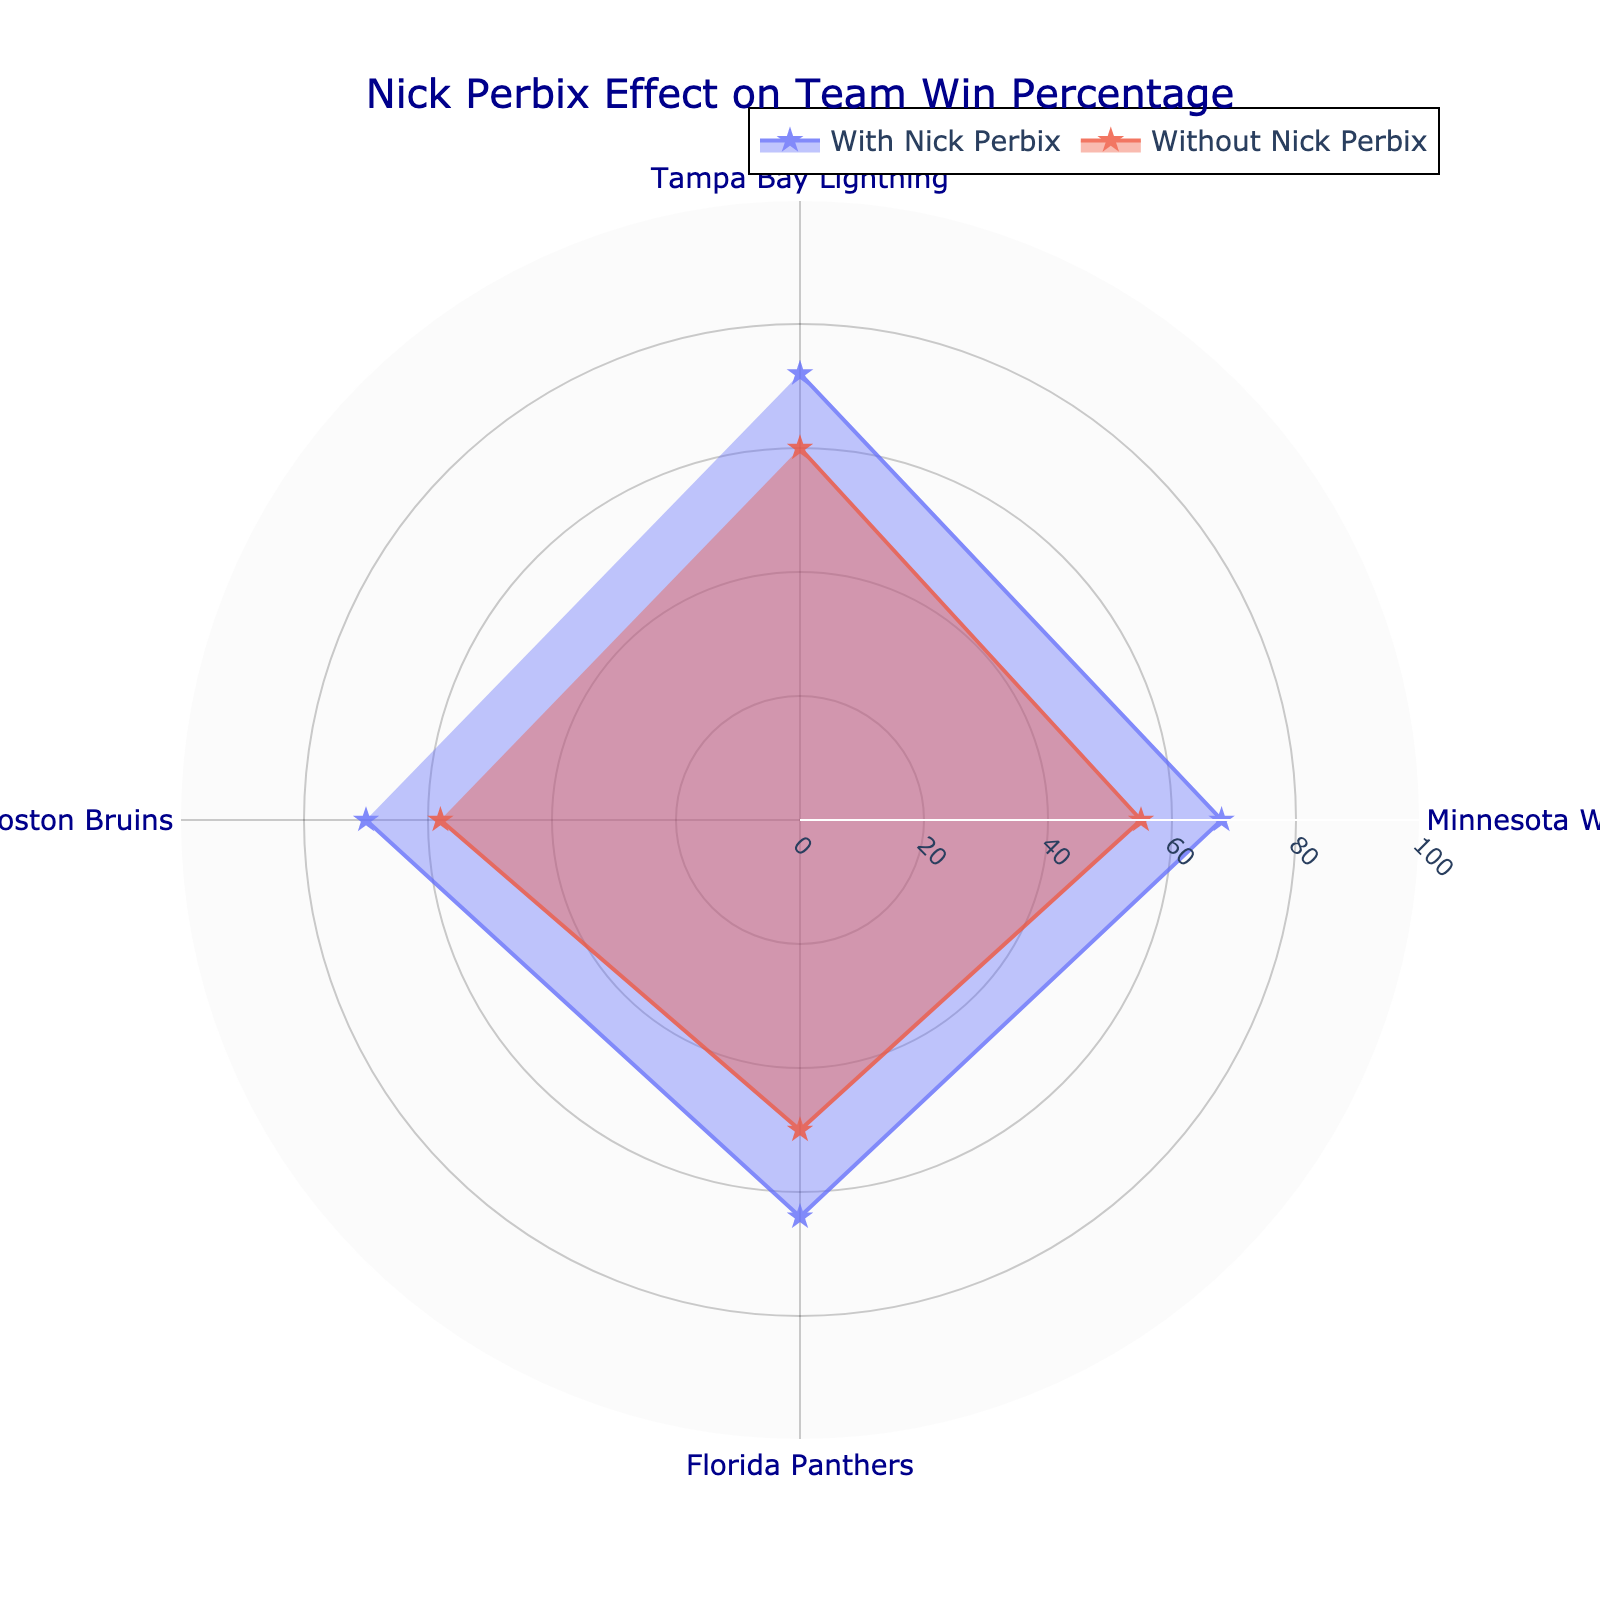What is the title of the figure? The title is located at the top of the figure in large, dark blue text.
Answer: Nick Perbix Effect on Team Win Percentage Which team has the highest win percentage with Nick Perbix in the lineup? The radial distance for “With Nick Perbix” condition shows that Tampa Bay Lightning has the highest percentage.
Answer: Tampa Bay Lightning How does the win percentage of the Minnesota Wild with Nick Perbix compare to their win percentage without him? Look at the two lines representing the Minnesota Wild; compare the radials for both conditions. With Nick Perbix: 68%, Without Nick Perbix: 55%.
Answer: 68% vs. 55% What is the average win percentage for Tampa Bay Lightning with and without Nick Perbix? Average Percentage = (Win Percentage With Nick Perbix + Win Percentage Without Nick Perbix) / 2. Plugging in the values: (72 + 60) / 2 = 66%
Answer: 66% What percentage improvement does the Florida Panthers show with Nick Perbix versus without him? Calculate the difference in the win percentage, then divide by the win percentage without Nick Perbix. ((64 - 50) / 50) × 100 = 28%
Answer: 28% Which condition has more teams with a win percentage of over 60%? Count the number of teams with win percentages above 60 for both “With Nick Perbix” and “Without Nick Perbix”.
Answer: With Nick Perbix How many teams have a win percentage of exactly 70% in any condition? Examine the plotted data points to check if any team reaches exactly 70%. Boston Bruins (With Nick Perbix) does.
Answer: 1 What is the total win percentage for all teams combined without Nick Perbix? Sum the win percentages for all teams without Nick Perbix: 60 + 55 + 50 + 58 = 223%
Answer: 223% By how much does Nick Perbix improve Boston Bruins' win percentage? Subtract the win percentage of Without Nick Perbix from With Nick Perbix: 70% - 58% = 12%
Answer: 12% Which team shows the smallest change in win percentage with and without Nick Perbix? Calculate the difference for each team. Lightning: 12%, Wild: 13%, Panthers: 14%, Bruins: 12%.
Answer: Tampa Bay Lightning & Boston Bruins 